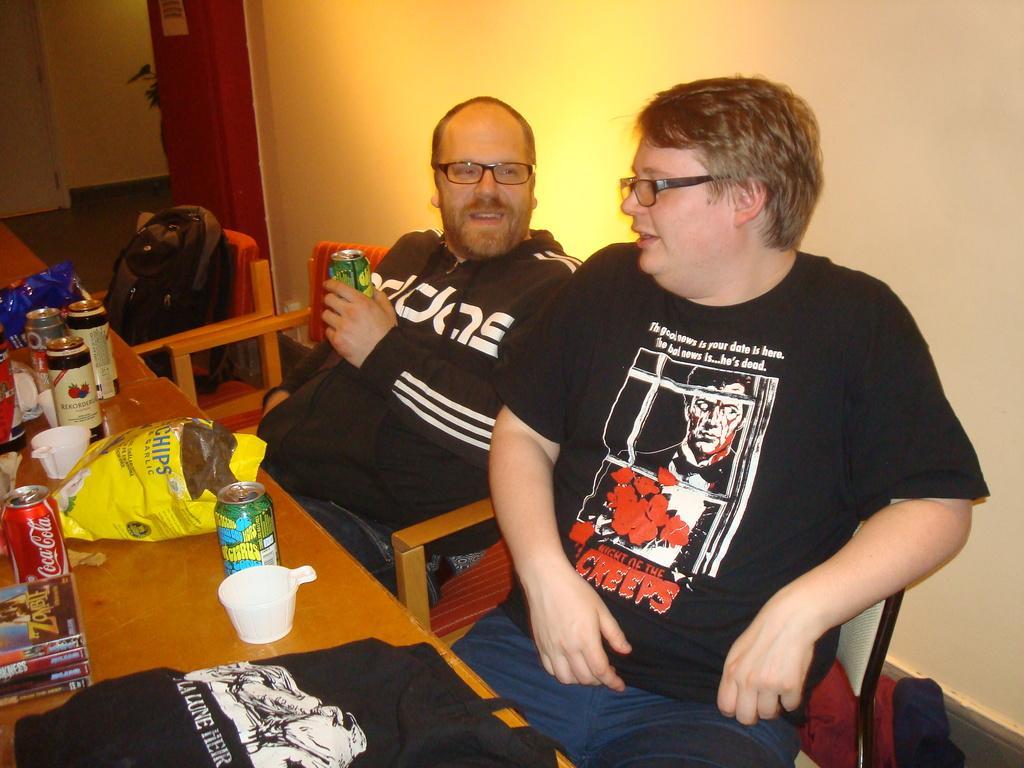Can you describe this image briefly? This picture shows the inner view of a room. There is one white door, one plant, one paper attached to the wall, three chairs, one bag is on the chair, two persons sitting on the chair and one person holding a Coke tin. So many different objects are on the table and one object on the surface. 